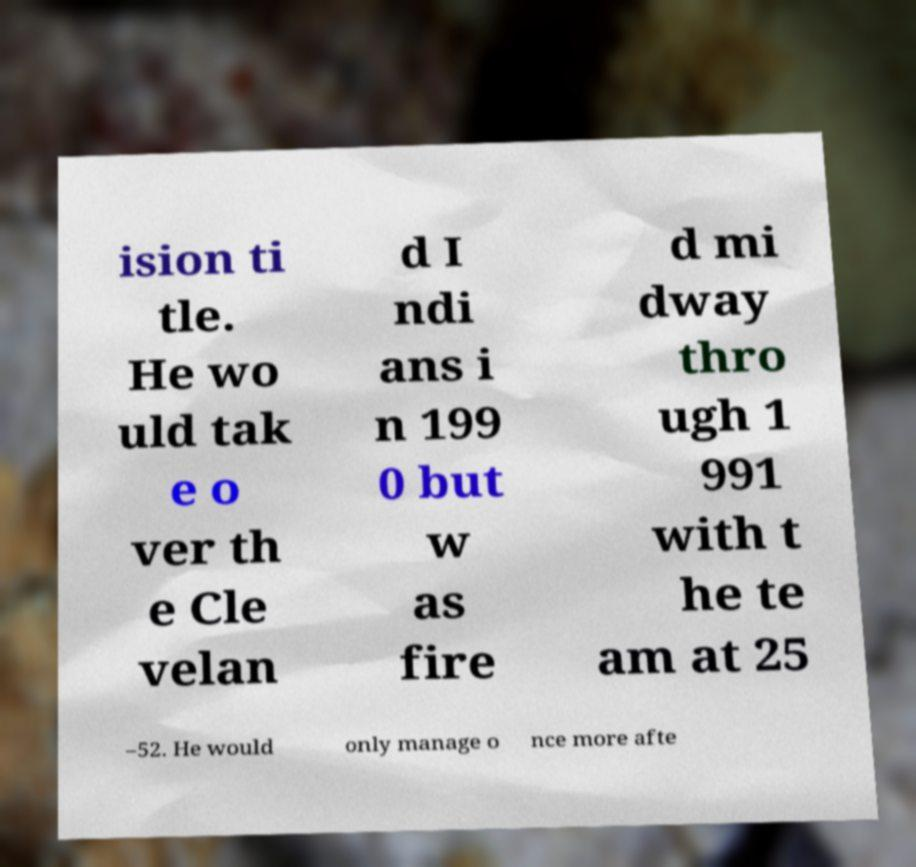Could you extract and type out the text from this image? ision ti tle. He wo uld tak e o ver th e Cle velan d I ndi ans i n 199 0 but w as fire d mi dway thro ugh 1 991 with t he te am at 25 –52. He would only manage o nce more afte 